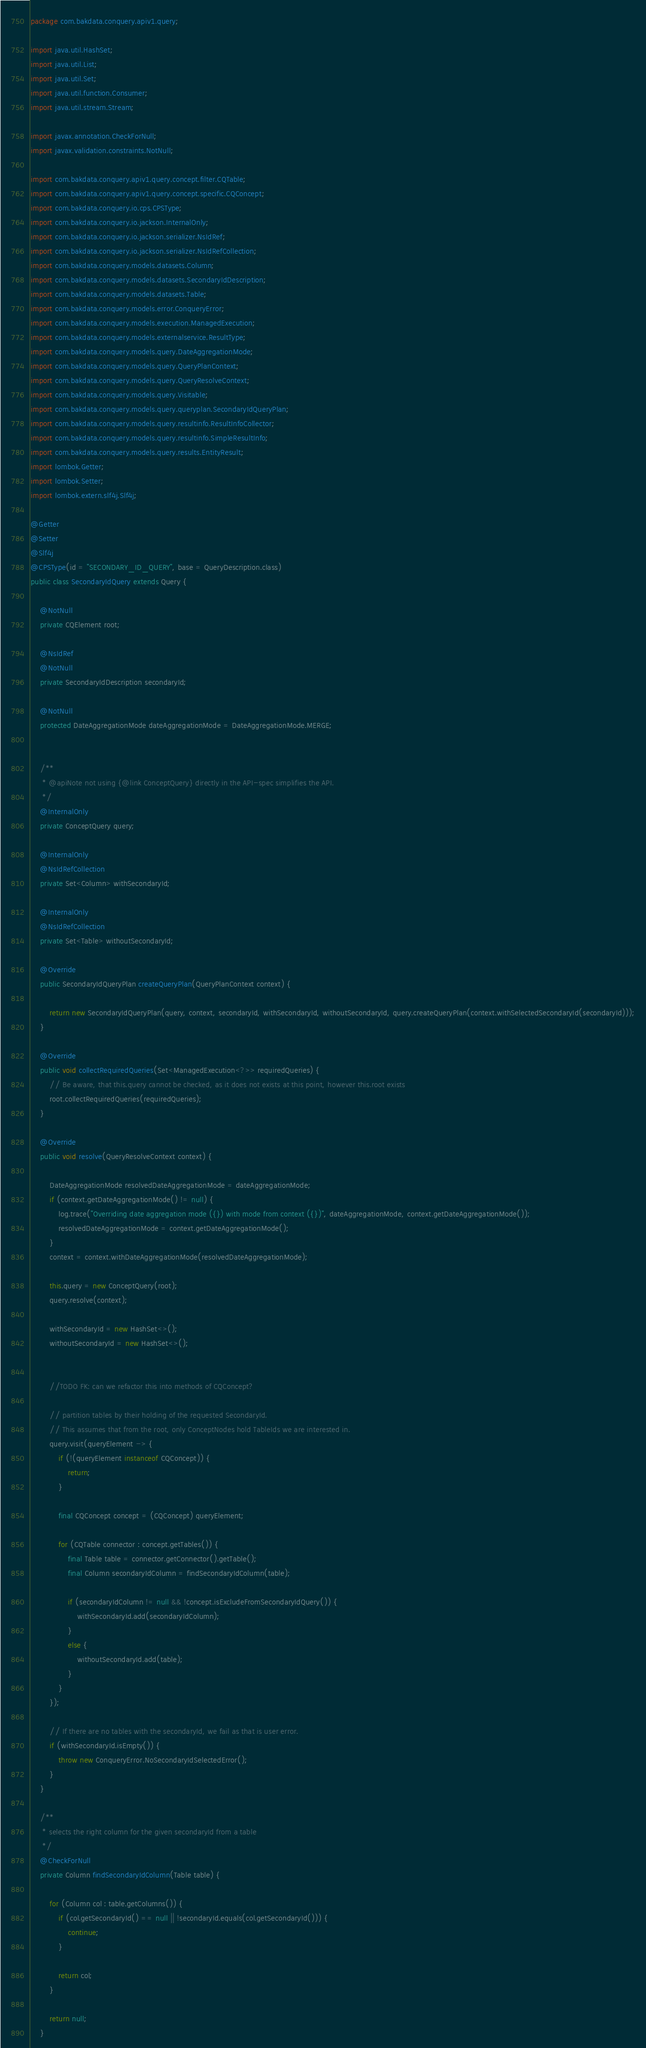Convert code to text. <code><loc_0><loc_0><loc_500><loc_500><_Java_>package com.bakdata.conquery.apiv1.query;

import java.util.HashSet;
import java.util.List;
import java.util.Set;
import java.util.function.Consumer;
import java.util.stream.Stream;

import javax.annotation.CheckForNull;
import javax.validation.constraints.NotNull;

import com.bakdata.conquery.apiv1.query.concept.filter.CQTable;
import com.bakdata.conquery.apiv1.query.concept.specific.CQConcept;
import com.bakdata.conquery.io.cps.CPSType;
import com.bakdata.conquery.io.jackson.InternalOnly;
import com.bakdata.conquery.io.jackson.serializer.NsIdRef;
import com.bakdata.conquery.io.jackson.serializer.NsIdRefCollection;
import com.bakdata.conquery.models.datasets.Column;
import com.bakdata.conquery.models.datasets.SecondaryIdDescription;
import com.bakdata.conquery.models.datasets.Table;
import com.bakdata.conquery.models.error.ConqueryError;
import com.bakdata.conquery.models.execution.ManagedExecution;
import com.bakdata.conquery.models.externalservice.ResultType;
import com.bakdata.conquery.models.query.DateAggregationMode;
import com.bakdata.conquery.models.query.QueryPlanContext;
import com.bakdata.conquery.models.query.QueryResolveContext;
import com.bakdata.conquery.models.query.Visitable;
import com.bakdata.conquery.models.query.queryplan.SecondaryIdQueryPlan;
import com.bakdata.conquery.models.query.resultinfo.ResultInfoCollector;
import com.bakdata.conquery.models.query.resultinfo.SimpleResultInfo;
import com.bakdata.conquery.models.query.results.EntityResult;
import lombok.Getter;
import lombok.Setter;
import lombok.extern.slf4j.Slf4j;

@Getter
@Setter
@Slf4j
@CPSType(id = "SECONDARY_ID_QUERY", base = QueryDescription.class)
public class SecondaryIdQuery extends Query {

	@NotNull
	private CQElement root;

	@NsIdRef
	@NotNull
	private SecondaryIdDescription secondaryId;

	@NotNull
	protected DateAggregationMode dateAggregationMode = DateAggregationMode.MERGE;


	/**
	 * @apiNote not using {@link ConceptQuery} directly in the API-spec simplifies the API.
	 */
	@InternalOnly
	private ConceptQuery query;

	@InternalOnly
	@NsIdRefCollection
	private Set<Column> withSecondaryId;

	@InternalOnly
	@NsIdRefCollection
	private Set<Table> withoutSecondaryId;

	@Override
	public SecondaryIdQueryPlan createQueryPlan(QueryPlanContext context) {

		return new SecondaryIdQueryPlan(query, context, secondaryId, withSecondaryId, withoutSecondaryId, query.createQueryPlan(context.withSelectedSecondaryId(secondaryId)));
	}

	@Override
	public void collectRequiredQueries(Set<ManagedExecution<?>> requiredQueries) {
		// Be aware, that this.query cannot be checked, as it does not exists at this point, however this.root exists
		root.collectRequiredQueries(requiredQueries);
	}

	@Override
	public void resolve(QueryResolveContext context) {

		DateAggregationMode resolvedDateAggregationMode = dateAggregationMode;
		if (context.getDateAggregationMode() != null) {
			log.trace("Overriding date aggregation mode ({}) with mode from context ({})", dateAggregationMode, context.getDateAggregationMode());
			resolvedDateAggregationMode = context.getDateAggregationMode();
		}
		context = context.withDateAggregationMode(resolvedDateAggregationMode);

		this.query = new ConceptQuery(root);
		query.resolve(context);

		withSecondaryId = new HashSet<>();
		withoutSecondaryId = new HashSet<>();


		//TODO FK: can we refactor this into methods of CQConcept?

		// partition tables by their holding of the requested SecondaryId.
		// This assumes that from the root, only ConceptNodes hold TableIds we are interested in.
		query.visit(queryElement -> {
			if (!(queryElement instanceof CQConcept)) {
				return;
			}

			final CQConcept concept = (CQConcept) queryElement;

			for (CQTable connector : concept.getTables()) {
				final Table table = connector.getConnector().getTable();
				final Column secondaryIdColumn = findSecondaryIdColumn(table);

				if (secondaryIdColumn != null && !concept.isExcludeFromSecondaryIdQuery()) {
					withSecondaryId.add(secondaryIdColumn);
				}
				else {
					withoutSecondaryId.add(table);
				}
			}
		});

		// If there are no tables with the secondaryId, we fail as that is user error.
		if (withSecondaryId.isEmpty()) {
			throw new ConqueryError.NoSecondaryIdSelectedError();
		}
	}

	/**
	 * selects the right column for the given secondaryId from a table
	 */
	@CheckForNull
	private Column findSecondaryIdColumn(Table table) {

		for (Column col : table.getColumns()) {
			if (col.getSecondaryId() == null || !secondaryId.equals(col.getSecondaryId())) {
				continue;
			}

			return col;
		}

		return null;
	}
</code> 